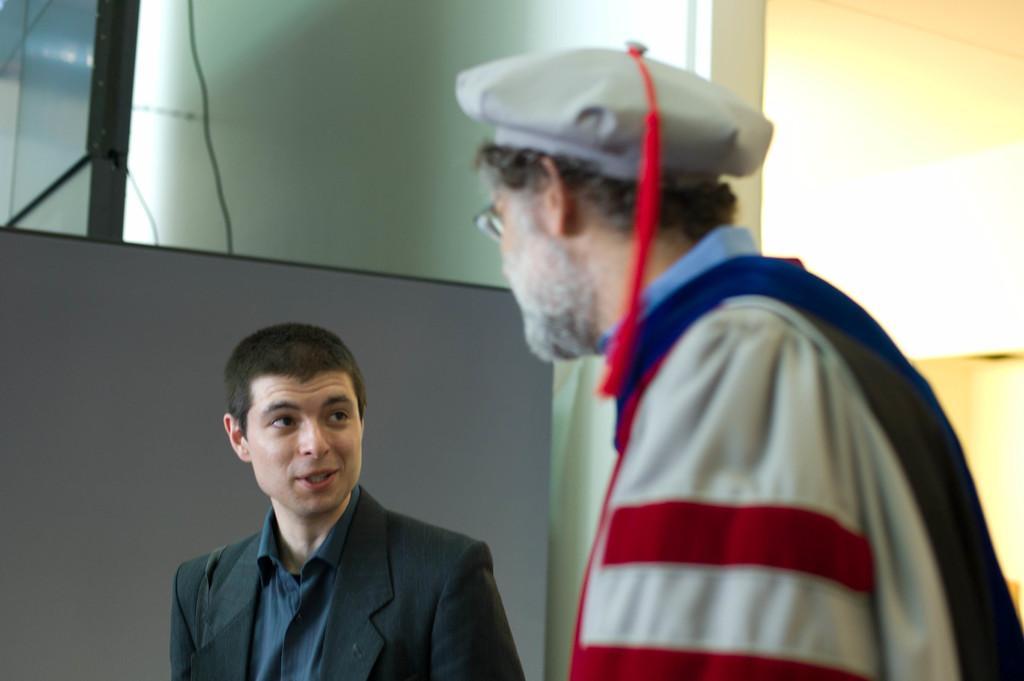Describe this image in one or two sentences. Here we can see two people. This person is looking at the opposite person. This man wore a cap. Background we can see wall, cable and boards. 